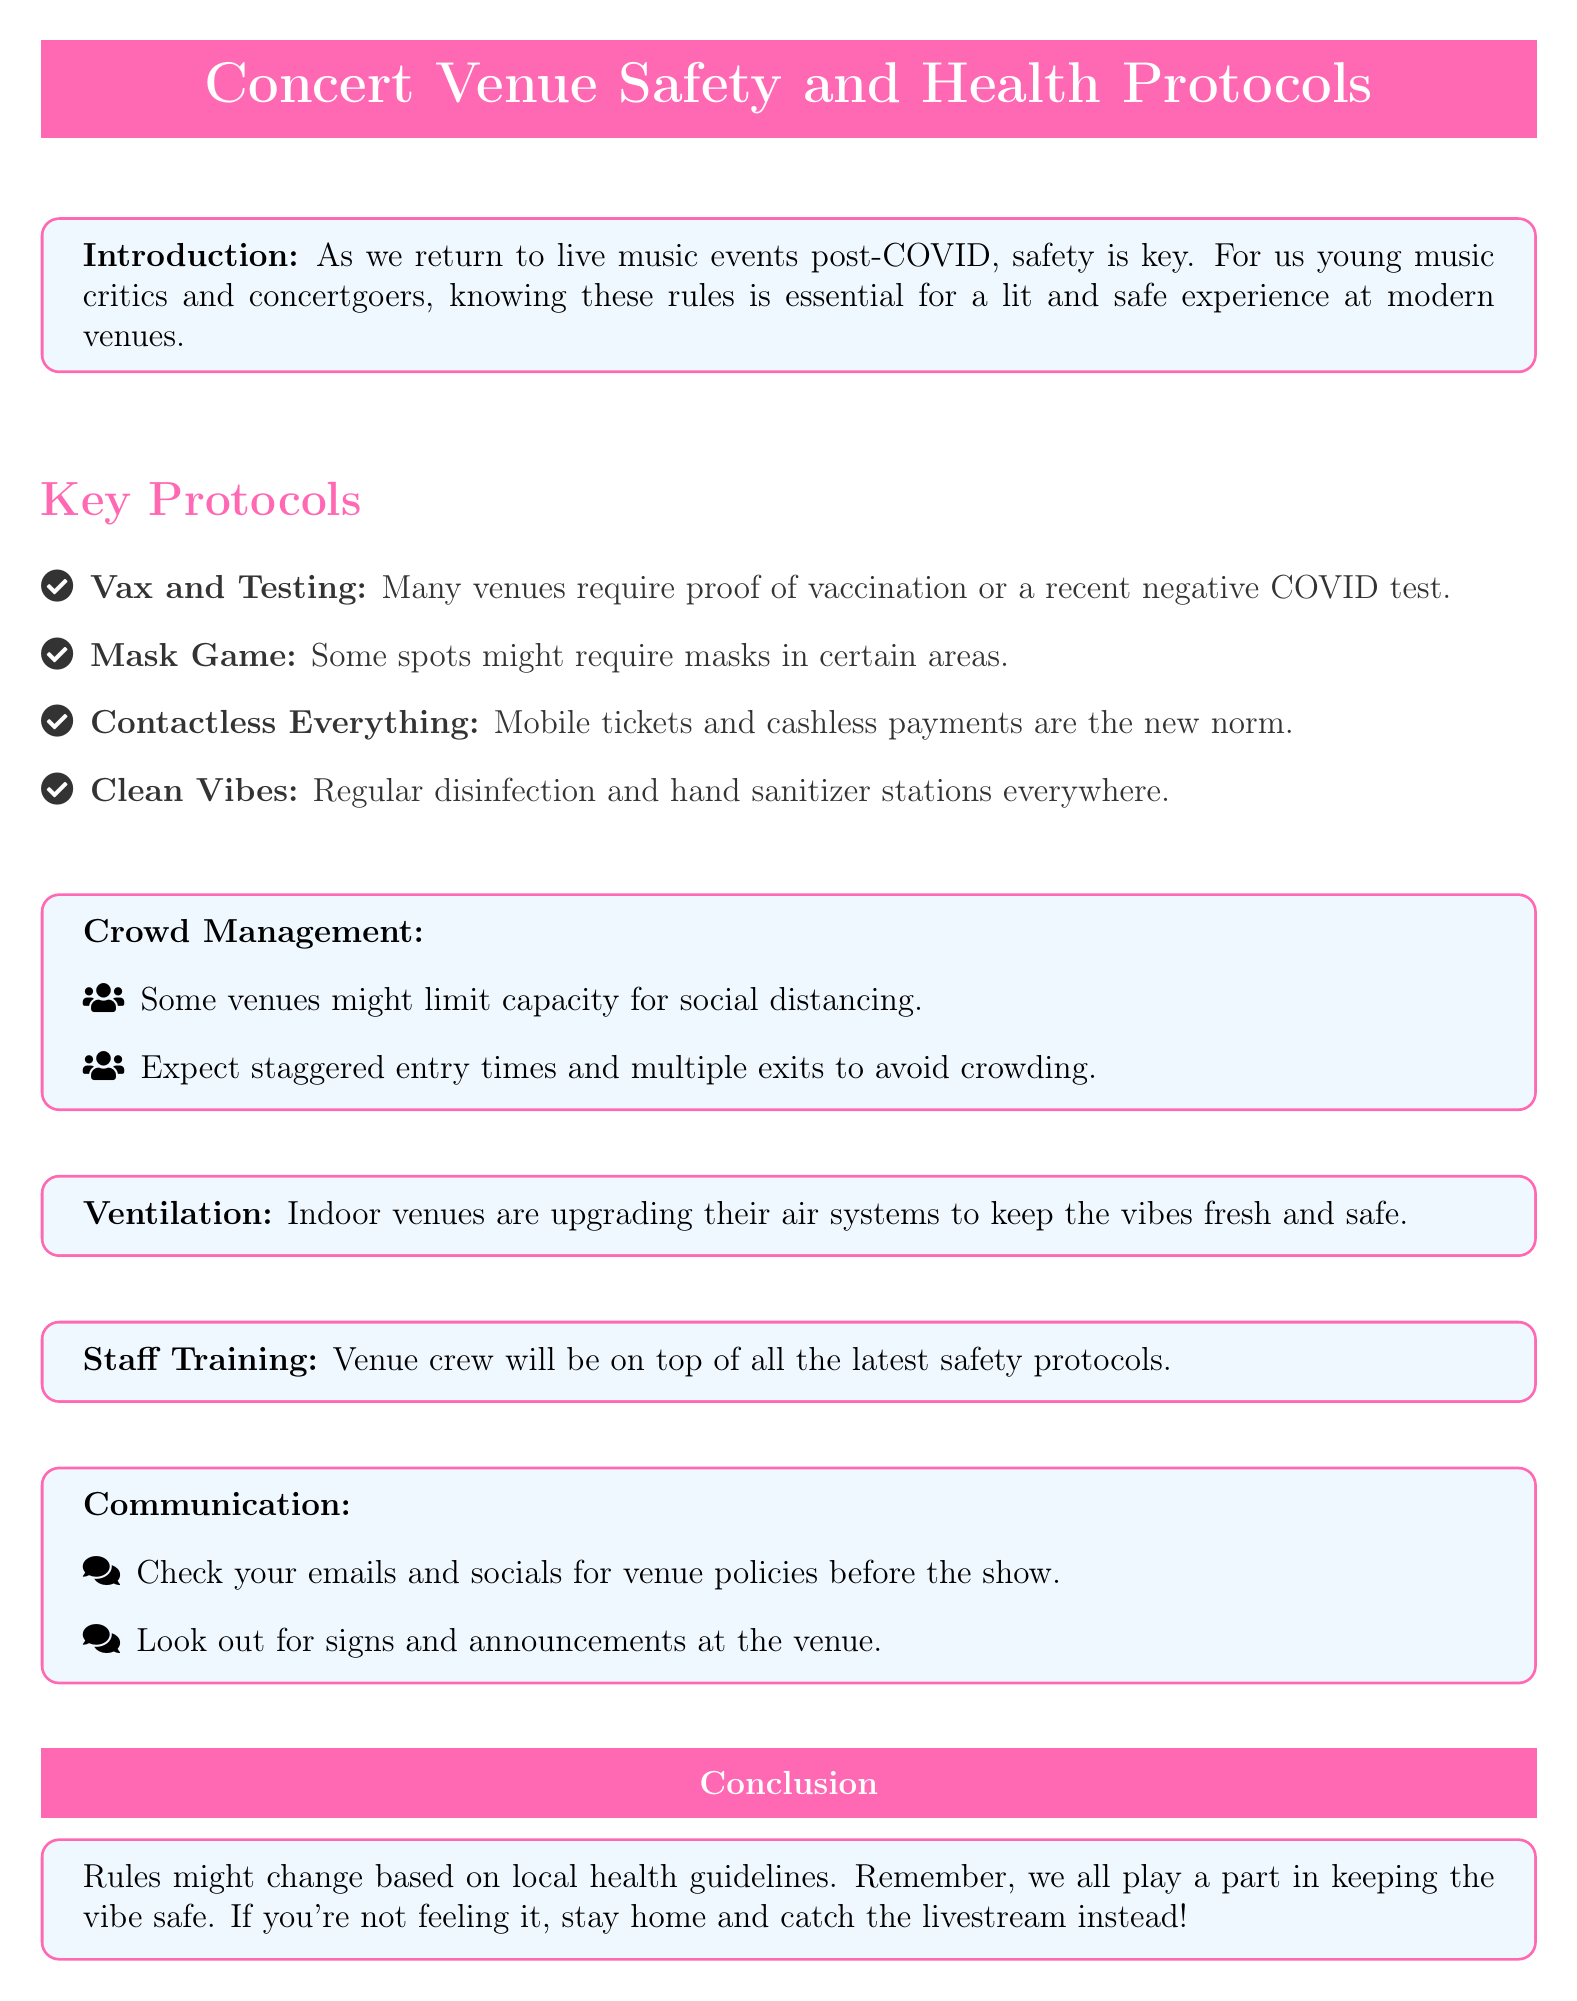What are the vaccination requirements? Many venues require proof of vaccination or a recent negative COVID test.
Answer: Proof of vaccination or a recent negative COVID test What is one method of contactless payment mentioned? The document specifies mobile tickets and cashless payments as the new norm.
Answer: Mobile tickets What is highlighted as being important for crowd management? The document mentions limiting capacity for social distancing as a key point.
Answer: Limiting capacity for social distancing What feature is upgraded in indoor venues? Venues are upgrading their air systems for better safety.
Answer: Air systems What should attendees do before the show regarding venue policies? The document suggests checking emails and socials for venue policies.
Answer: Check emails and socials Why is it necessary for venue staff to receive training? Staff training is important to be updated on the latest safety protocols.
Answer: Latest safety protocols What is the purpose of hand sanitizer stations? Regular disinfection and hand sanitizer stations are meant to ensure cleanliness.
Answer: Ensure cleanliness What is the concluding statement about attendance? If someone isn't feeling well, the document advises staying home and catching the livestream.
Answer: Stay home and catch the livestream 